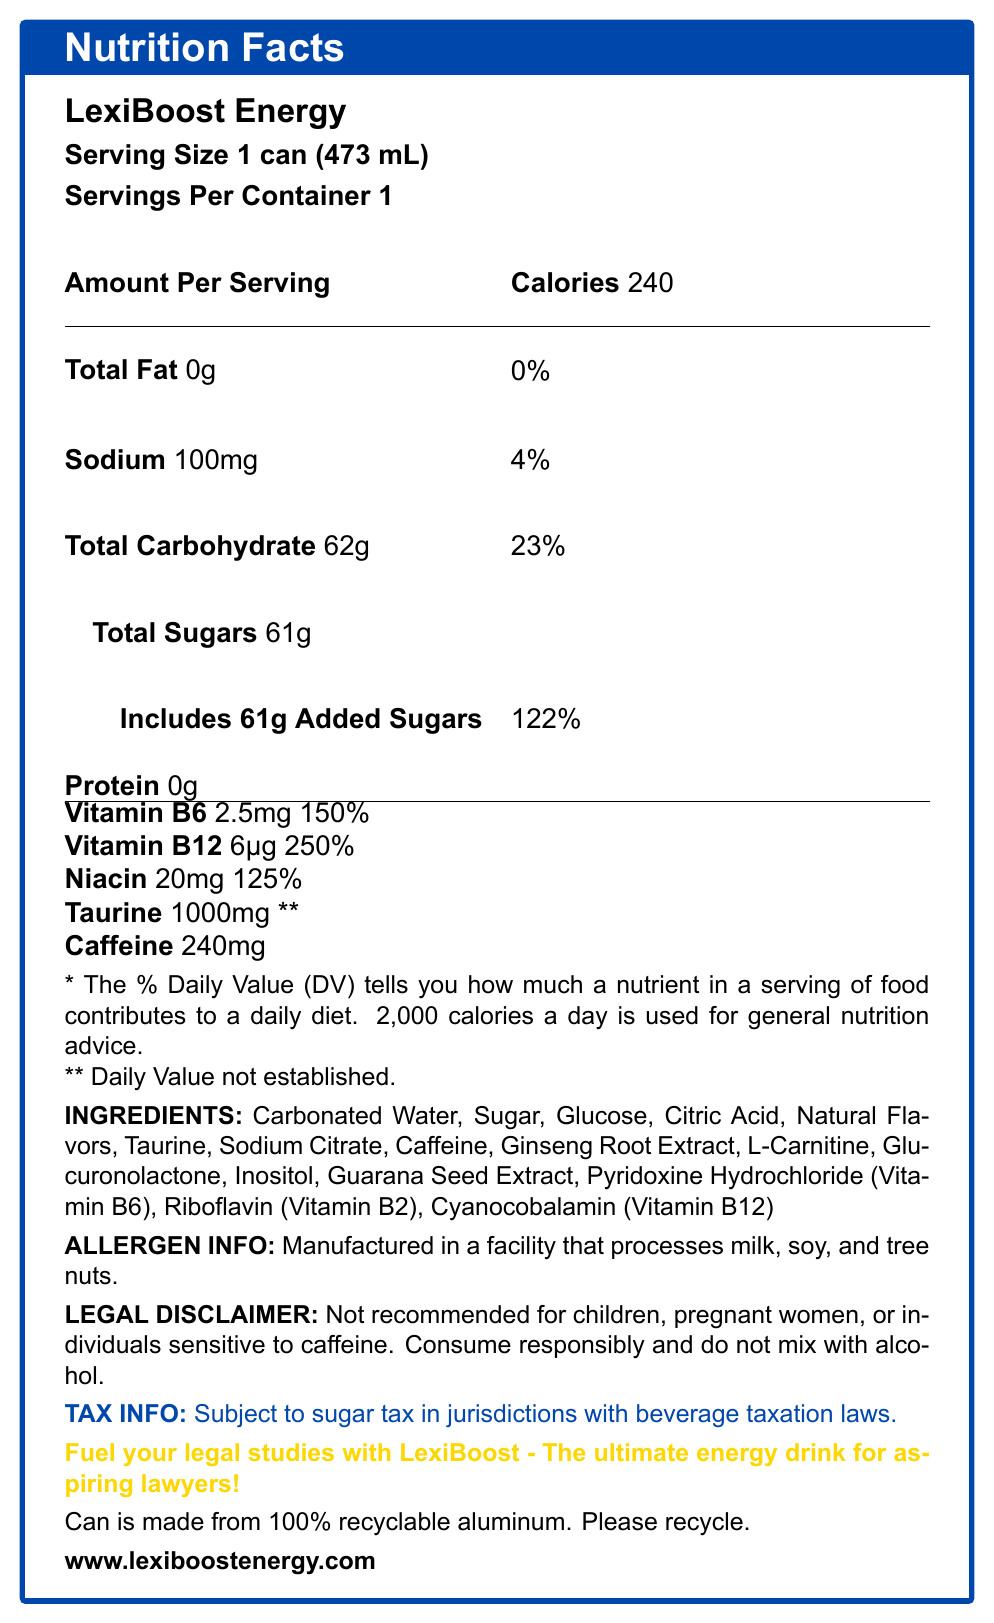what is the serving size of LexiBoost Energy? The document specifies the serving size as "1 can (473 mL)".
Answer: 1 can (473 mL) how many calories are in one can of LexiBoost Energy? The document lists "Calories" as 240.
Answer: 240 what is the total amount of sugars in LexiBoost Energy? The document indicates "Total Sugars" as 61g.
Answer: 61g how much caffeine does LexiBoost Energy contain? The document specifies "Caffeine" as 240mg.
Answer: 240mg what percentage of the daily value of Vitamin B12 does LexiBoost Energy provide? The document shows "Vitamin B12" provides 250% of the daily value.
Answer: 250% which ingredient is listed first in LexiBoost Energy? A. Sugar B. Carbonated Water C. Caffeine According to the document, the first ingredient listed is "Carbonated Water".
Answer: B which mineral or vitamin has the highest daily value percentage in LexiBoost Energy? A. Niacin B. Vitamin B6 C. Vitamin B12 The document details that "Vitamin B12" has the highest daily value percentage at 250%.
Answer: C is LexiBoost Energy recommended for children? The legal disclaimer in the document states that it is "Not recommended for children".
Answer: No does LexiBoost Energy contain any protein? The document lists "Protein" as 0g.
Answer: No summarize the main idea of the nutrition label for LexiBoost Energy. The nutrition label details the calorie content, ingredient list, allergens, and other nutritional data specific to LexiBoost Energy, promoting it as an ideal energy source for law students.
Answer: LexiBoost Energy is an energy drink designed for aspiring lawyers, containing high levels of caffeine, significant amounts of added sugars, and several B vitamins. It has 240 calories per serving and includes various ingredients like taurine and ginseng root extract. The drink is manufactured in a facility that processes common allergens and is subject to sugar tax. is there any information about the potential benefits of ginseng root extract in LexiBoost Energy? The document lists ginseng root extract as an ingredient but does not provide details on its potential benefits.
Answer: Not enough information who should avoid consuming LexiBoost Energy according to the legal disclaimer? The legal disclaimer specifically advises against consumption by children, pregnant women, or individuals sensitive to caffeine.
Answer: Children, pregnant women, and individuals sensitive to caffeine what is the total carbohydrate content in LexiBoost Energy in terms of grams and daily value percentage? The document indicates that the total carbohydrate content is 62g, which is 23% of the daily value.
Answer: 62g, 23% what type of packaging is used for LexiBoost Energy? The sustainability note in the document mentions the can is made from 100% recyclable aluminum.
Answer: 100% recyclable aluminum can will you be subject to a sugar tax if you purchase LexiBoost Energy in a jurisdiction with beverage taxation laws? The tax info section states the energy drink is subject to sugar tax in jurisdictions with beverage taxation laws.
Answer: Yes 